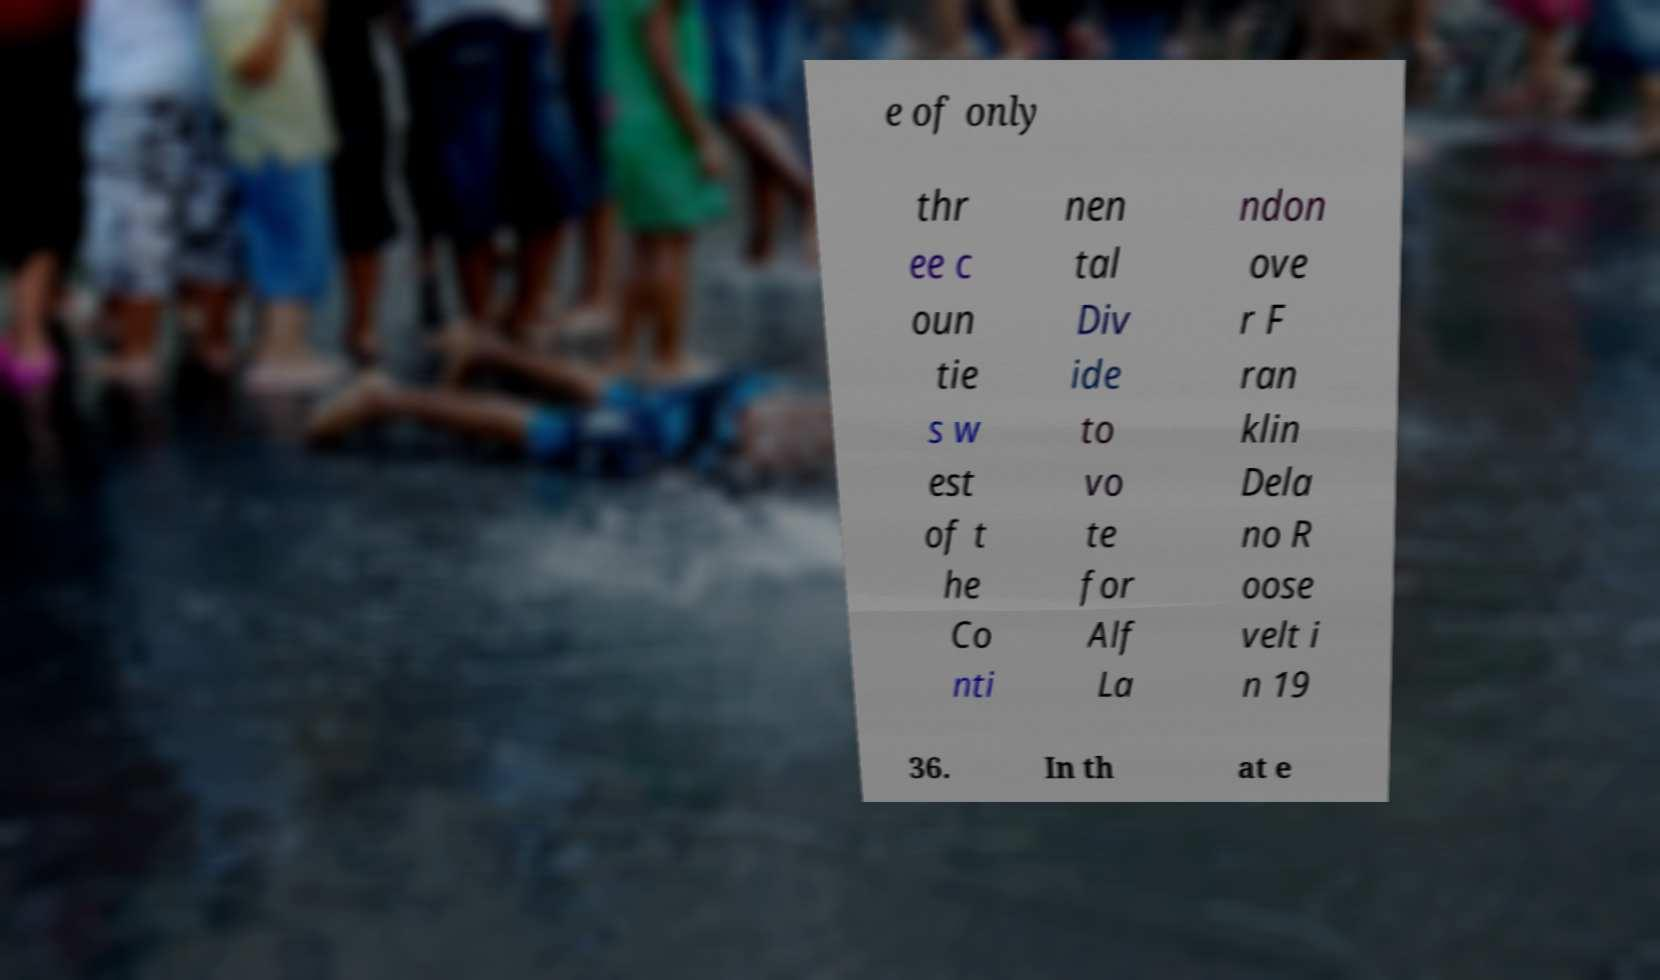There's text embedded in this image that I need extracted. Can you transcribe it verbatim? e of only thr ee c oun tie s w est of t he Co nti nen tal Div ide to vo te for Alf La ndon ove r F ran klin Dela no R oose velt i n 19 36. In th at e 